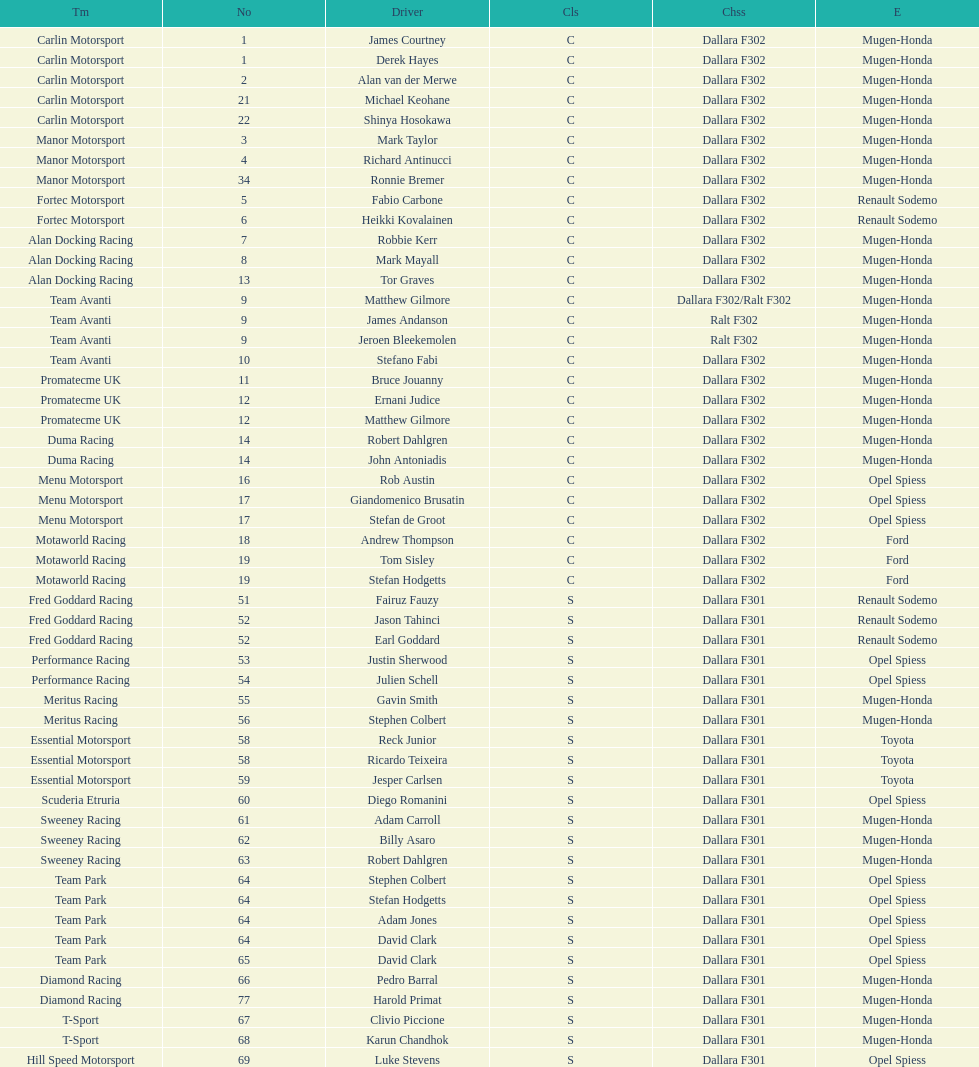Comparing team avanti and motaworld racing, which team had a greater number of drivers? Team Avanti. 